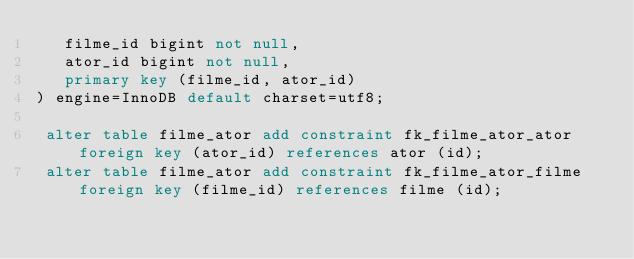<code> <loc_0><loc_0><loc_500><loc_500><_SQL_>   filme_id bigint not null,
   ator_id bigint not null,
   primary key (filme_id, ator_id)
) engine=InnoDB default charset=utf8;

 alter table filme_ator add constraint fk_filme_ator_ator foreign key (ator_id) references ator (id);
 alter table filme_ator add constraint fk_filme_ator_filme foreign key (filme_id) references filme (id);</code> 